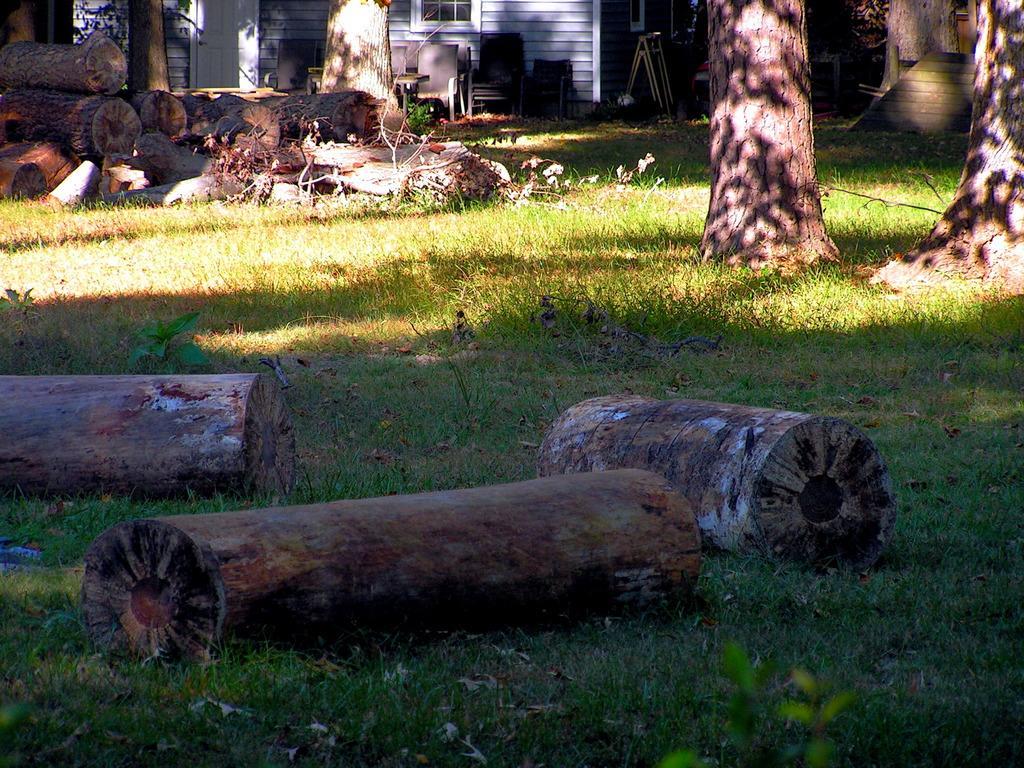Please provide a concise description of this image. In this image I can see trunks kept on grass and I can see chairs and the wall and window and door visible at the top and I can see a stair case on the right side 